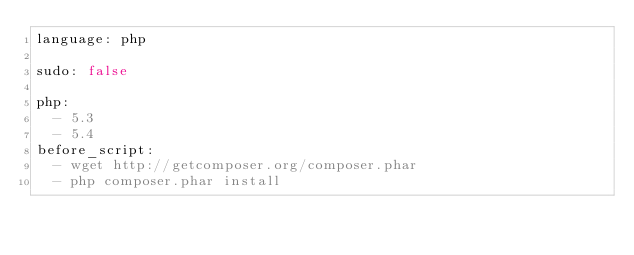<code> <loc_0><loc_0><loc_500><loc_500><_YAML_>language: php

sudo: false 

php:
  - 5.3
  - 5.4
before_script:
  - wget http://getcomposer.org/composer.phar
  - php composer.phar install
</code> 